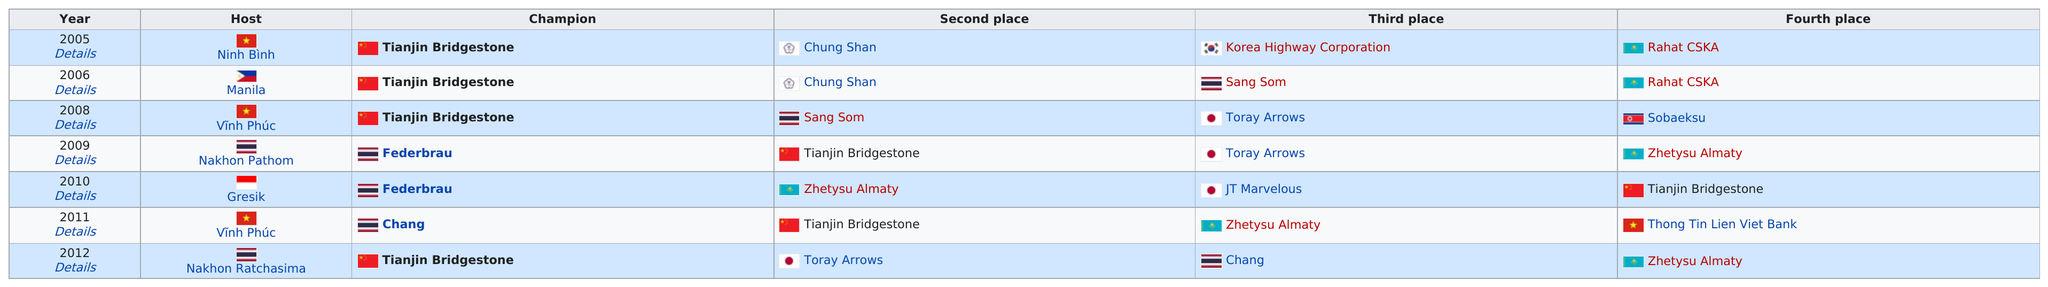List a handful of essential elements in this visual. Has Chung Shan won second place in the AVC Championship more times than Toray Arrows? Tianjin Bridgestone won the AVC Club Championship four times. The Tianjin Bridgestone is the first champion of the AVC Club Championship. In 2006, Tianjin Bridgestone won the AVC Championship, starting a three-year streak that continued until 2008. However, in 2009, Federbrau emerged as the new champion, marking the end of Tianjin Bridgestone's dominant run. Arrows won third place two times. 